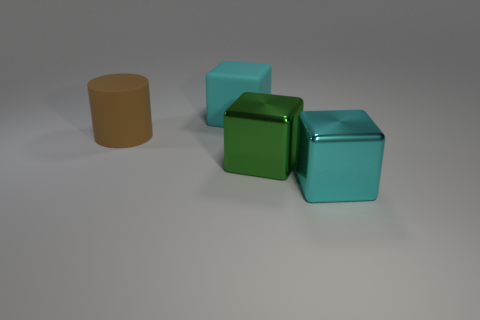Add 2 matte blocks. How many objects exist? 6 Subtract all cylinders. How many objects are left? 3 Subtract all small red metallic cylinders. Subtract all large cylinders. How many objects are left? 3 Add 3 large metallic objects. How many large metallic objects are left? 5 Add 4 large green shiny objects. How many large green shiny objects exist? 5 Subtract 0 brown blocks. How many objects are left? 4 